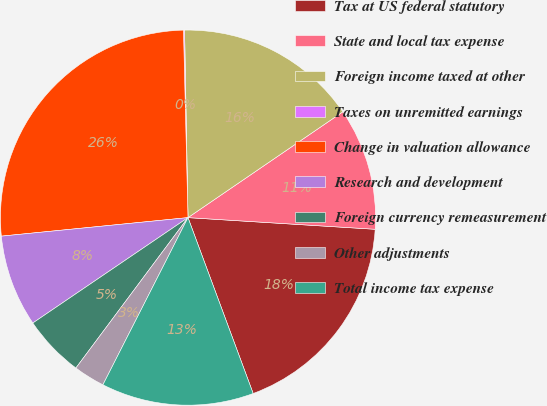Convert chart to OTSL. <chart><loc_0><loc_0><loc_500><loc_500><pie_chart><fcel>Tax at US federal statutory<fcel>State and local tax expense<fcel>Foreign income taxed at other<fcel>Taxes on unremitted earnings<fcel>Change in valuation allowance<fcel>Research and development<fcel>Foreign currency remeasurement<fcel>Other adjustments<fcel>Total income tax expense<nl><fcel>18.36%<fcel>10.53%<fcel>15.75%<fcel>0.09%<fcel>26.19%<fcel>7.92%<fcel>5.31%<fcel>2.7%<fcel>13.14%<nl></chart> 